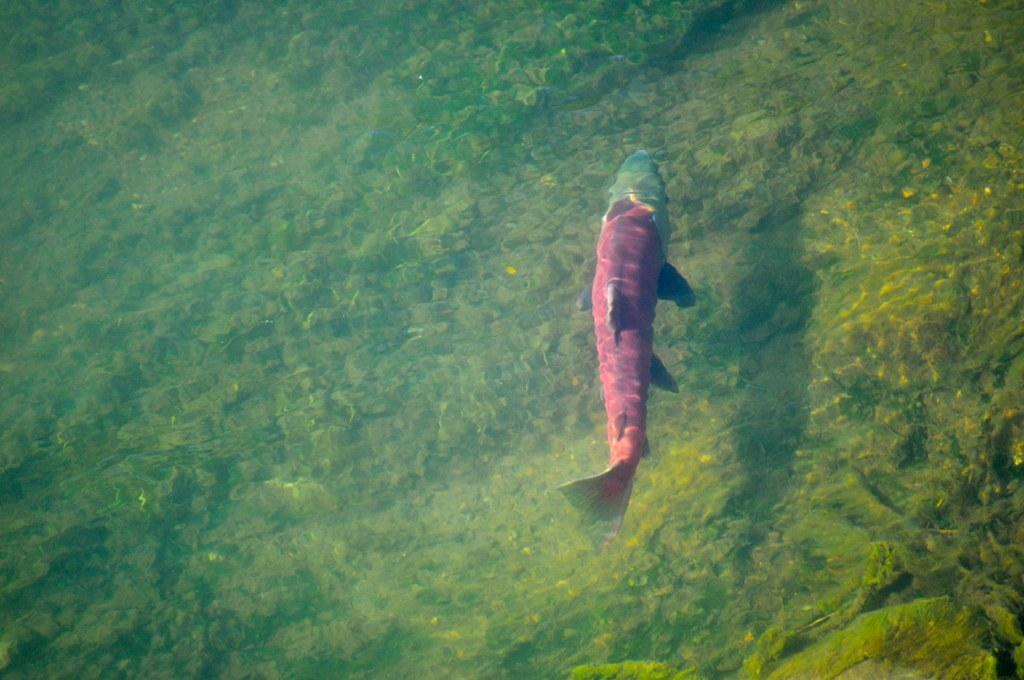What type of animal can be seen in the water in the image? There is a fish in the water in the image. What can be seen at the bottom of the image? There is grass and stones at the bottom of the image. What word is the fish trying to spell out with the stones at the bottom of the image? There is no indication that the fish is trying to spell out a word with the stones in the image. 